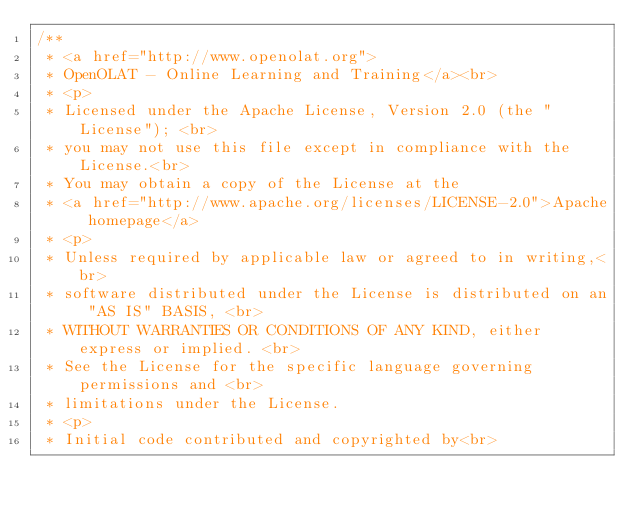Convert code to text. <code><loc_0><loc_0><loc_500><loc_500><_Java_>/**
 * <a href="http://www.openolat.org">
 * OpenOLAT - Online Learning and Training</a><br>
 * <p>
 * Licensed under the Apache License, Version 2.0 (the "License"); <br>
 * you may not use this file except in compliance with the License.<br>
 * You may obtain a copy of the License at the
 * <a href="http://www.apache.org/licenses/LICENSE-2.0">Apache homepage</a>
 * <p>
 * Unless required by applicable law or agreed to in writing,<br>
 * software distributed under the License is distributed on an "AS IS" BASIS, <br>
 * WITHOUT WARRANTIES OR CONDITIONS OF ANY KIND, either express or implied. <br>
 * See the License for the specific language governing permissions and <br>
 * limitations under the License.
 * <p>
 * Initial code contributed and copyrighted by<br></code> 